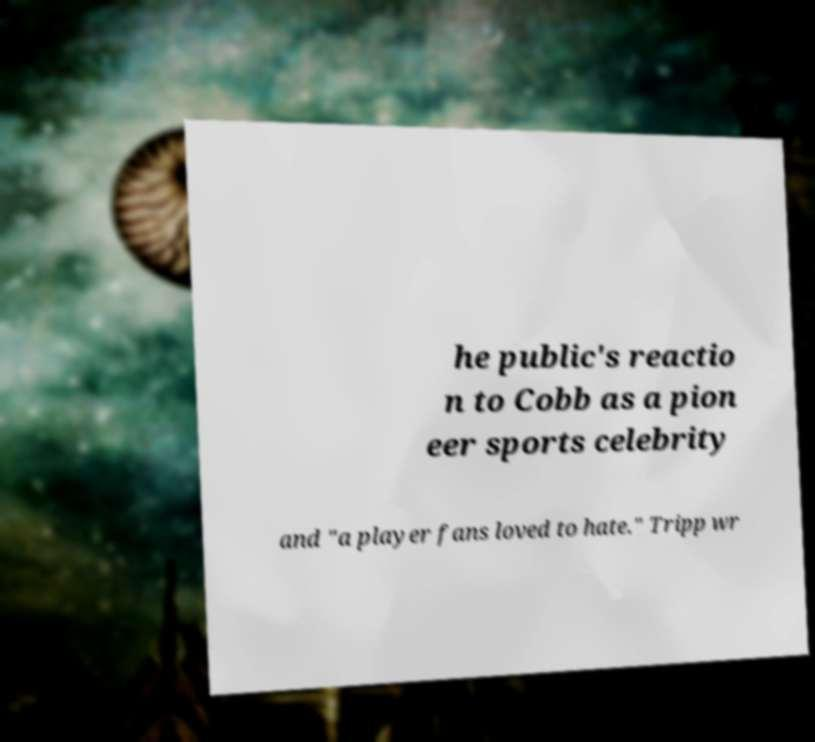Please read and relay the text visible in this image. What does it say? he public's reactio n to Cobb as a pion eer sports celebrity and "a player fans loved to hate." Tripp wr 